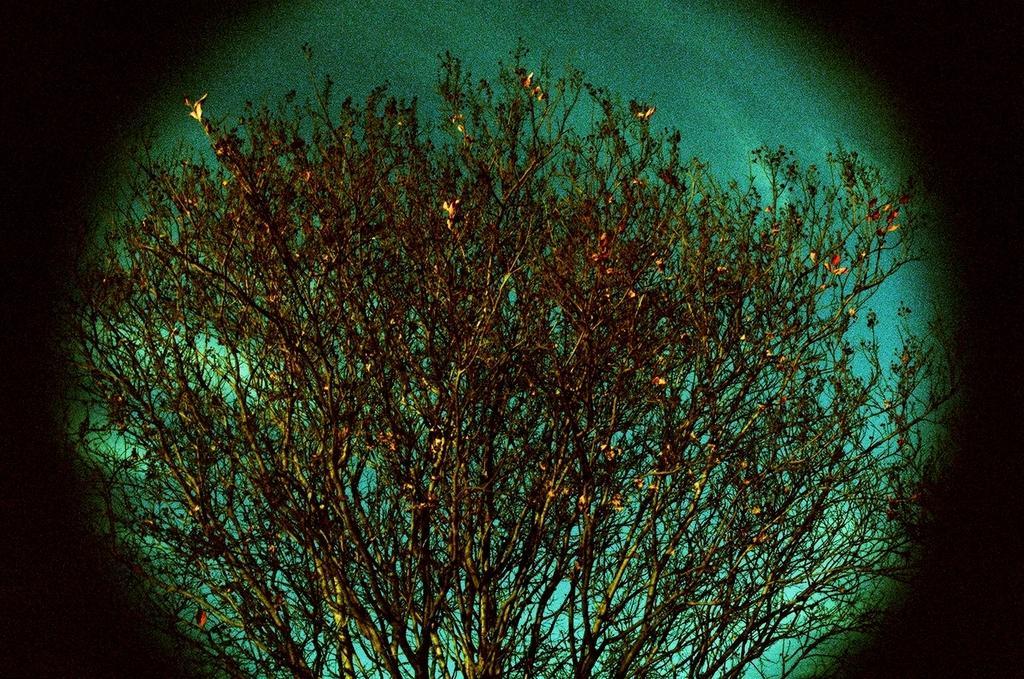In one or two sentences, can you explain what this image depicts? In this picture I can see number of trees and in the background I can see the sky and I see that this picture is a bit in dark. 